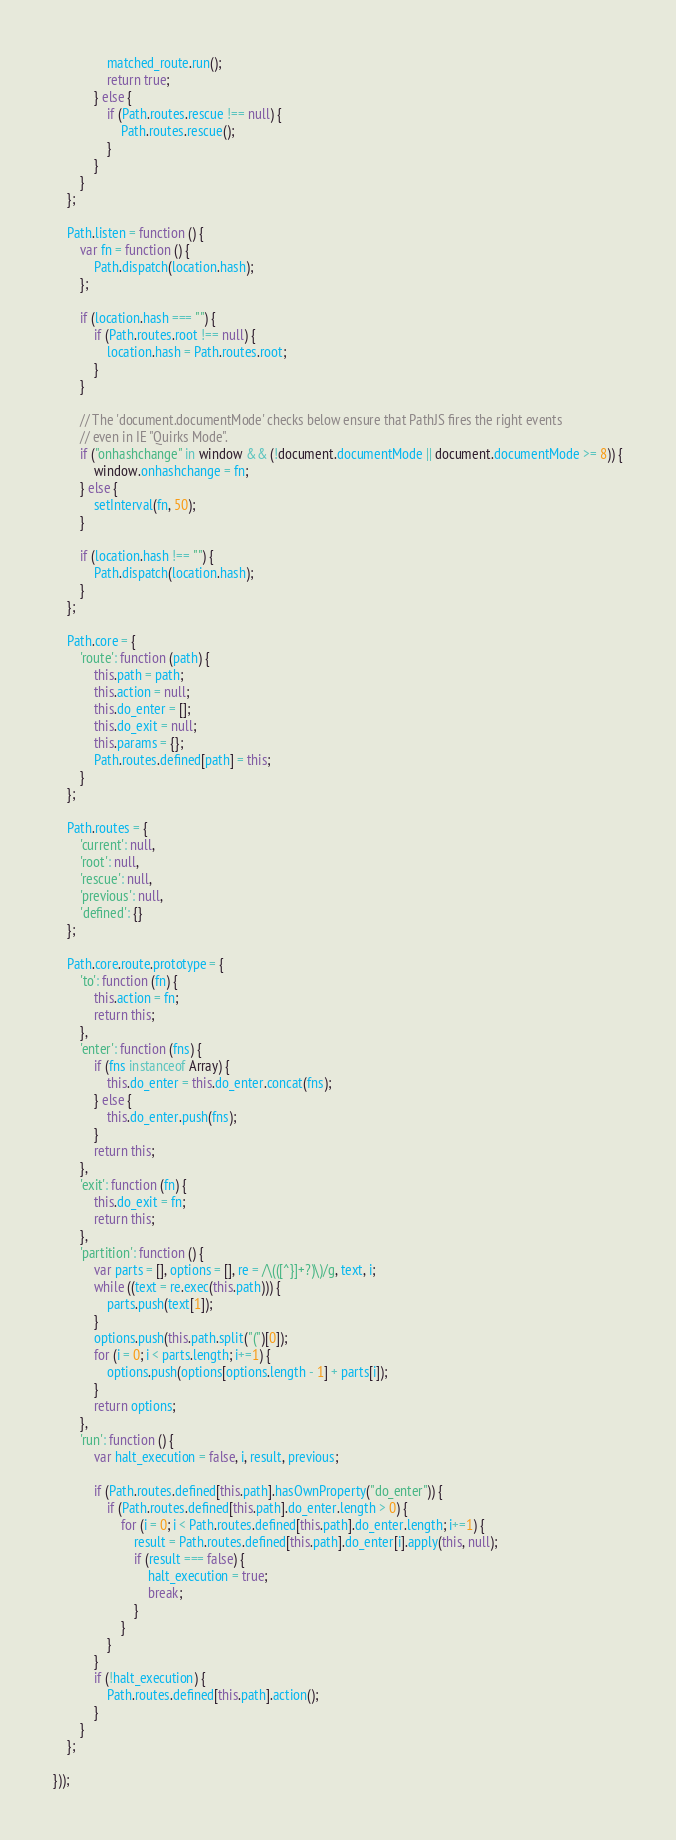<code> <loc_0><loc_0><loc_500><loc_500><_JavaScript_>                matched_route.run();
                return true;
            } else {
                if (Path.routes.rescue !== null) {
                    Path.routes.rescue();
                }
            }
        }
    };

    Path.listen = function () {
        var fn = function () {
            Path.dispatch(location.hash);
        };

        if (location.hash === "") {
            if (Path.routes.root !== null) {
                location.hash = Path.routes.root;
            }
        }

        // The 'document.documentMode' checks below ensure that PathJS fires the right events
        // even in IE "Quirks Mode".
        if ("onhashchange" in window && (!document.documentMode || document.documentMode >= 8)) {
            window.onhashchange = fn;
        } else {
            setInterval(fn, 50);
        }

        if (location.hash !== "") {
            Path.dispatch(location.hash);
        }
    };

    Path.core = {
        'route': function (path) {
            this.path = path;
            this.action = null;
            this.do_enter = [];
            this.do_exit = null;
            this.params = {};
            Path.routes.defined[path] = this;
        }
    };

    Path.routes = {
        'current': null,
        'root': null,
        'rescue': null,
        'previous': null,
        'defined': {}
    };

    Path.core.route.prototype = {
        'to': function (fn) {
            this.action = fn;
            return this;
        },
        'enter': function (fns) {
            if (fns instanceof Array) {
                this.do_enter = this.do_enter.concat(fns);
            } else {
                this.do_enter.push(fns);
            }
            return this;
        },
        'exit': function (fn) {
            this.do_exit = fn;
            return this;
        },
        'partition': function () {
            var parts = [], options = [], re = /\(([^}]+?)\)/g, text, i;
            while ((text = re.exec(this.path))) {
                parts.push(text[1]);
            }
            options.push(this.path.split("(")[0]);
            for (i = 0; i < parts.length; i+=1) {
                options.push(options[options.length - 1] + parts[i]);
            }
            return options;
        },
        'run': function () {
            var halt_execution = false, i, result, previous;

            if (Path.routes.defined[this.path].hasOwnProperty("do_enter")) {
                if (Path.routes.defined[this.path].do_enter.length > 0) {
                    for (i = 0; i < Path.routes.defined[this.path].do_enter.length; i+=1) {
                        result = Path.routes.defined[this.path].do_enter[i].apply(this, null);
                        if (result === false) {
                            halt_execution = true;
                            break;
                        }
                    }
                }
            }
            if (!halt_execution) {
                Path.routes.defined[this.path].action();
            }
        }
    };

}));
</code> 